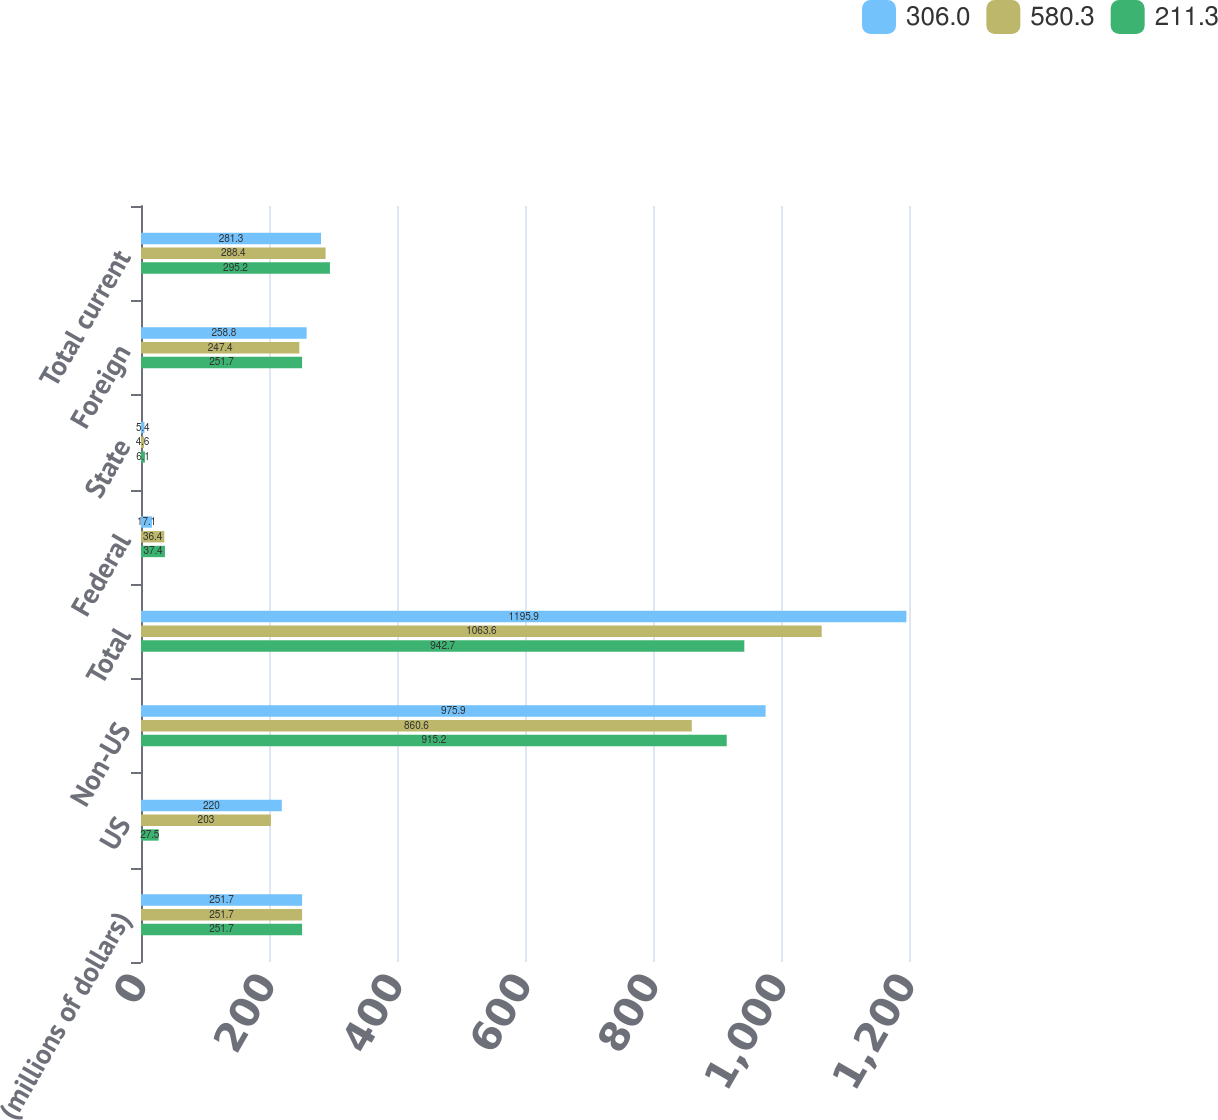Convert chart. <chart><loc_0><loc_0><loc_500><loc_500><stacked_bar_chart><ecel><fcel>(millions of dollars)<fcel>US<fcel>Non-US<fcel>Total<fcel>Federal<fcel>State<fcel>Foreign<fcel>Total current<nl><fcel>306<fcel>251.7<fcel>220<fcel>975.9<fcel>1195.9<fcel>17.1<fcel>5.4<fcel>258.8<fcel>281.3<nl><fcel>580.3<fcel>251.7<fcel>203<fcel>860.6<fcel>1063.6<fcel>36.4<fcel>4.6<fcel>247.4<fcel>288.4<nl><fcel>211.3<fcel>251.7<fcel>27.5<fcel>915.2<fcel>942.7<fcel>37.4<fcel>6.1<fcel>251.7<fcel>295.2<nl></chart> 